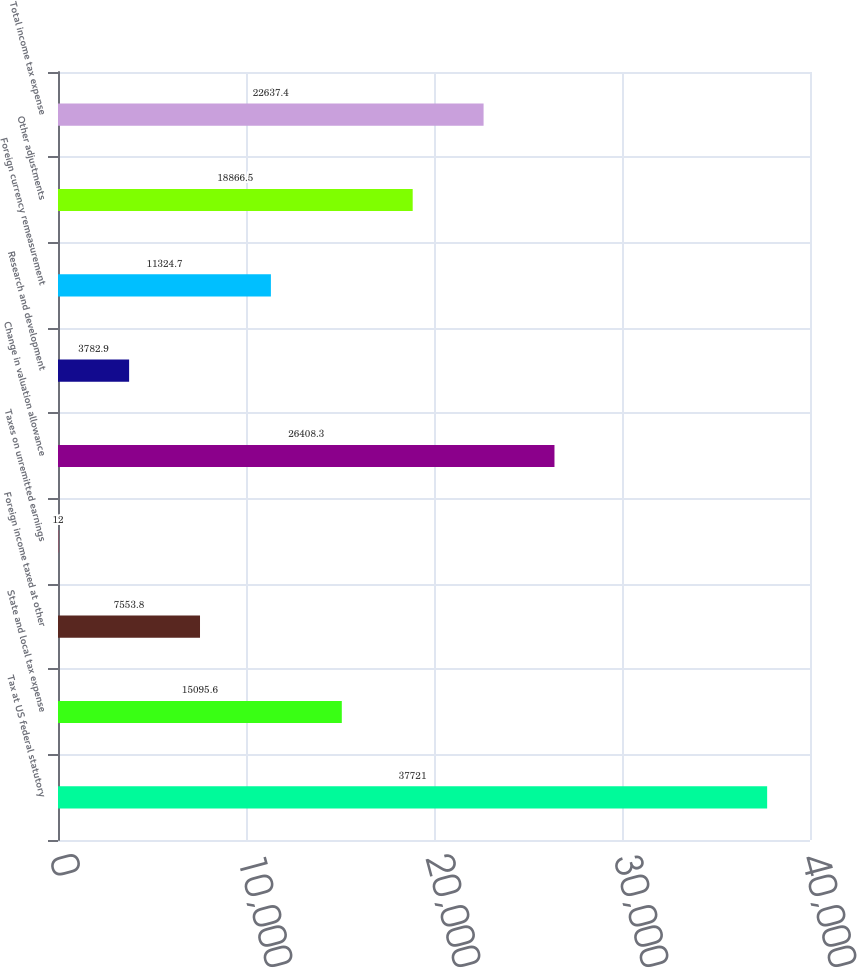<chart> <loc_0><loc_0><loc_500><loc_500><bar_chart><fcel>Tax at US federal statutory<fcel>State and local tax expense<fcel>Foreign income taxed at other<fcel>Taxes on unremitted earnings<fcel>Change in valuation allowance<fcel>Research and development<fcel>Foreign currency remeasurement<fcel>Other adjustments<fcel>Total income tax expense<nl><fcel>37721<fcel>15095.6<fcel>7553.8<fcel>12<fcel>26408.3<fcel>3782.9<fcel>11324.7<fcel>18866.5<fcel>22637.4<nl></chart> 